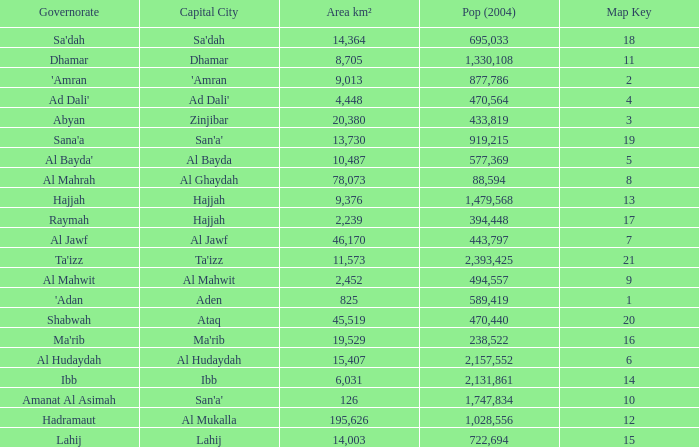How many Pop (2004) has a Governorate of al mahwit? 494557.0. 